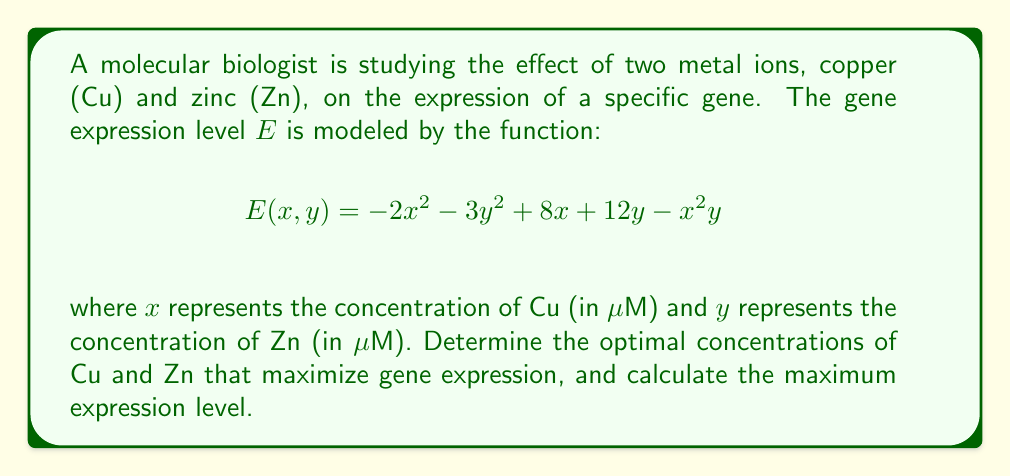Help me with this question. To find the optimal concentrations that maximize gene expression, we need to find the global maximum of the function E(x, y). We can do this by following these steps:

1. Calculate the partial derivatives of E with respect to x and y:
   $$\frac{\partial E}{\partial x} = -4x + 8 - 2xy$$
   $$\frac{\partial E}{\partial y} = -6y + 12 - x^2$$

2. Set both partial derivatives to zero to find critical points:
   $$-4x + 8 - 2xy = 0 \quad (1)$$
   $$-6y + 12 - x^2 = 0 \quad (2)$$

3. From equation (2), we can express y in terms of x:
   $$y = 2 - \frac{x^2}{6} \quad (3)$$

4. Substitute (3) into equation (1):
   $$-4x + 8 - 2x(2 - \frac{x^2}{6}) = 0$$
   $$-4x + 8 - 4x + \frac{x^3}{3} = 0$$
   $$\frac{x^3}{3} - 8x + 8 = 0$$
   $$x^3 - 24x + 24 = 0$$

5. This cubic equation can be factored:
   $$(x - 2)(x^2 + 2x - 12) = 0$$
   $$(x - 2)(x + 6)(x - 4) = 0$$

   The solutions are x = 2, x = 4, and x = -6 (which we can discard as concentration cannot be negative)

6. Substitute these x values back into equation (3) to find corresponding y values:
   For x = 2: y = 2 - (2^2)/6 = 5/3
   For x = 4: y = 2 - (4^2)/6 = 2/3

7. Calculate E(x, y) for both points:
   E(2, 5/3) ≈ 20.89
   E(4, 2/3) ≈ 21.33

8. Check the boundaries and corners of the domain (assuming non-negative concentrations):
   E(0, 0) = 0
   E(0, y) has a maximum at y = 2, E(0, 2) = 24
   E(x, 0) has a maximum at x = 2, E(2, 0) = 12

Therefore, the global maximum occurs at E(0, 2), which gives a higher value than the critical points found earlier.
Answer: Optimal concentrations: Cu = 0 μM, Zn = 2 μM; Maximum expression level: 24 